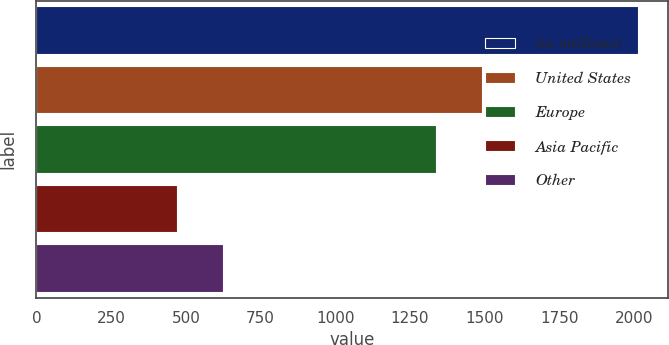Convert chart. <chart><loc_0><loc_0><loc_500><loc_500><bar_chart><fcel>(in millions)<fcel>United States<fcel>Europe<fcel>Asia Pacific<fcel>Other<nl><fcel>2012<fcel>1492.3<fcel>1338<fcel>469<fcel>623.3<nl></chart> 